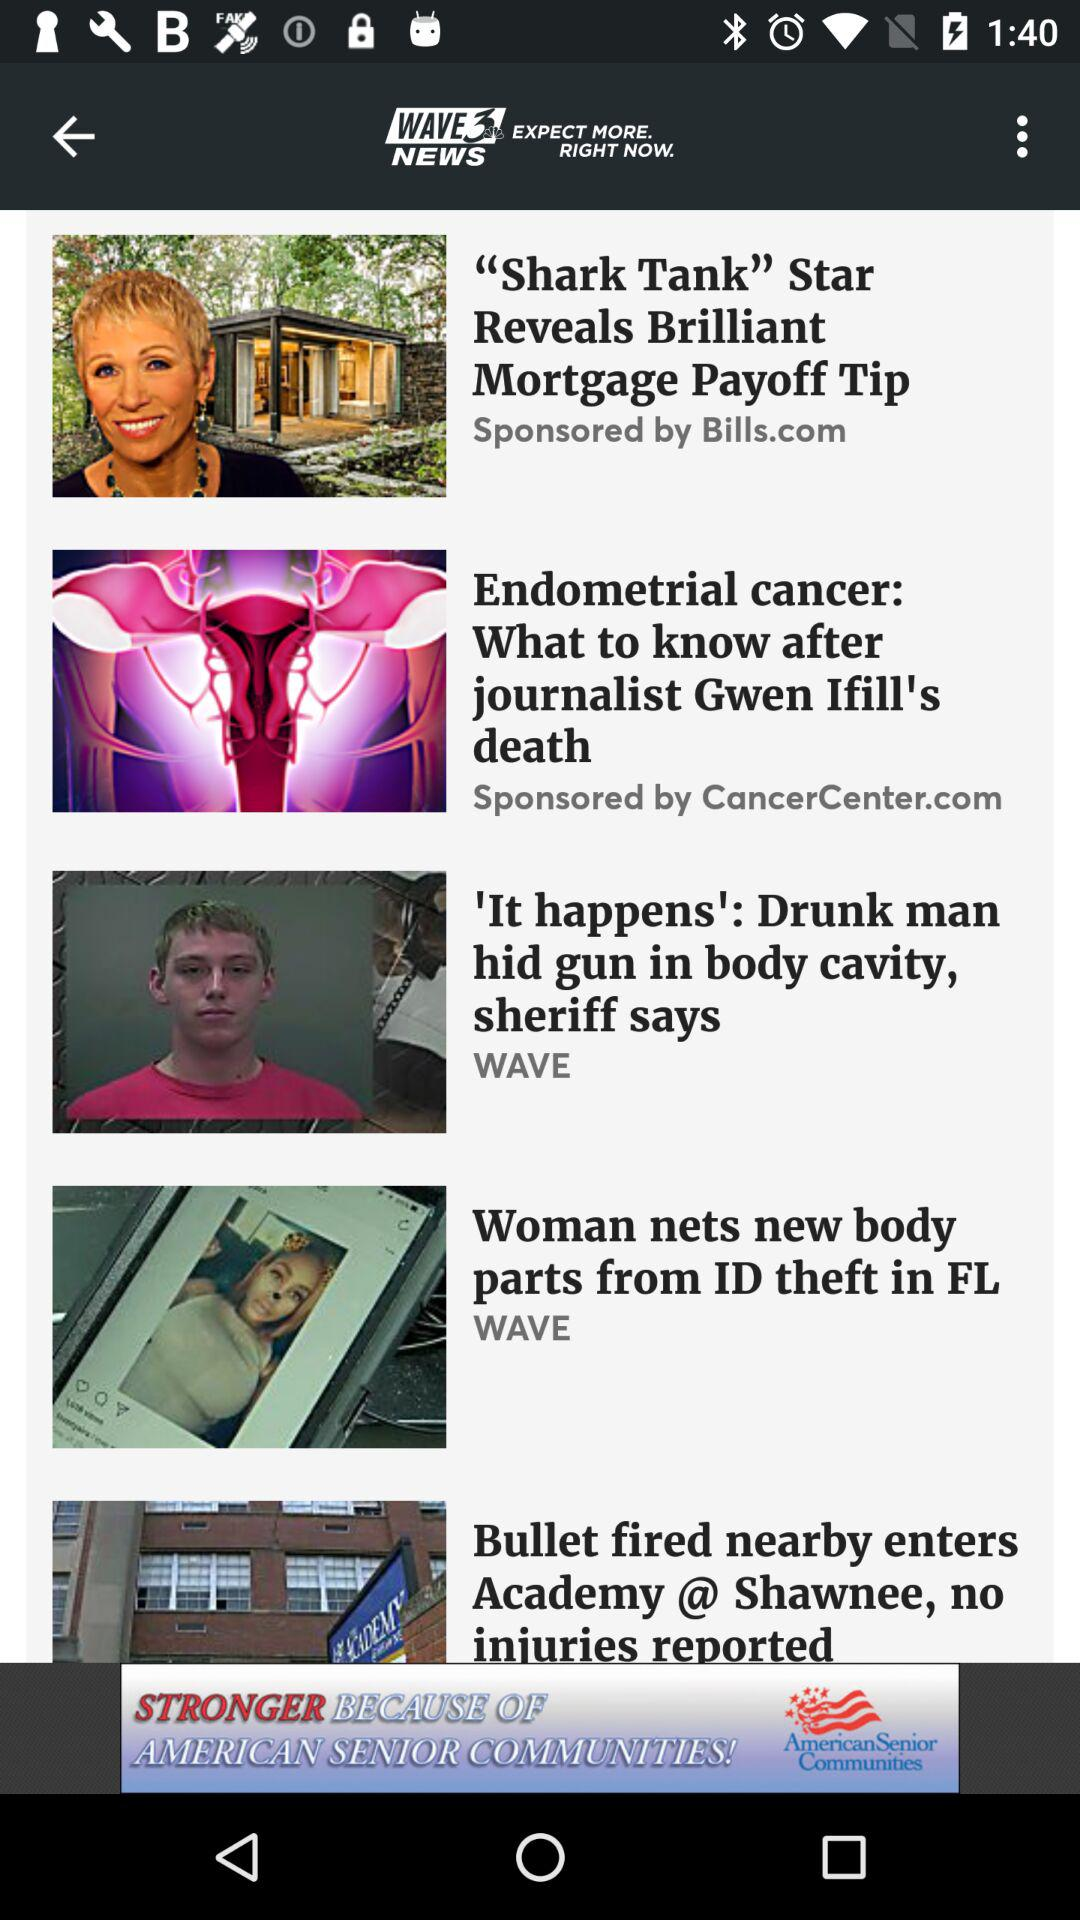Who sponsored "Shark Tank"? "Shark Tank" is sponsored by Bills.com. 